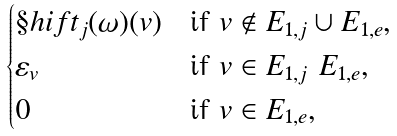Convert formula to latex. <formula><loc_0><loc_0><loc_500><loc_500>\begin{cases} \S h i f t _ { j } ( \omega ) ( v ) & \text {if $v \not\in E_{1,j} \cup E_{1,e}$} , \\ \varepsilon _ { v } & \text {if $v \in E_{1,j} \ E_{1,e}$} , \\ 0 & \text {if $v \in E_{1,e}$} , \end{cases}</formula> 